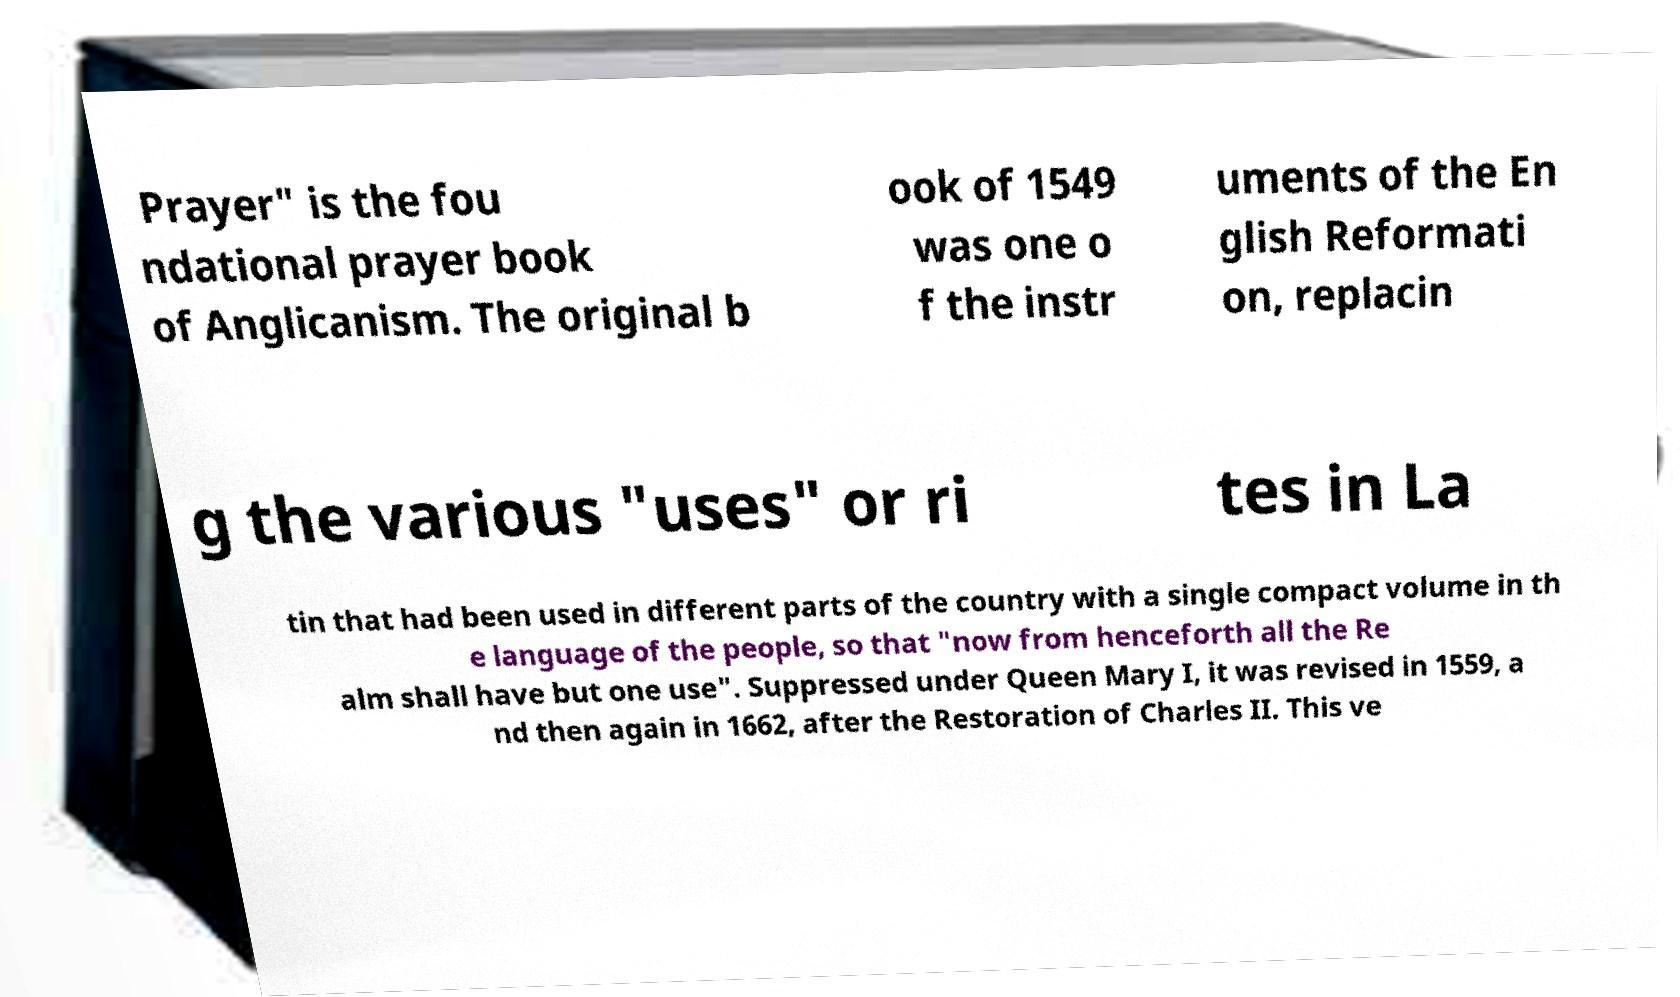Could you extract and type out the text from this image? Prayer" is the fou ndational prayer book of Anglicanism. The original b ook of 1549 was one o f the instr uments of the En glish Reformati on, replacin g the various "uses" or ri tes in La tin that had been used in different parts of the country with a single compact volume in th e language of the people, so that "now from henceforth all the Re alm shall have but one use". Suppressed under Queen Mary I, it was revised in 1559, a nd then again in 1662, after the Restoration of Charles II. This ve 